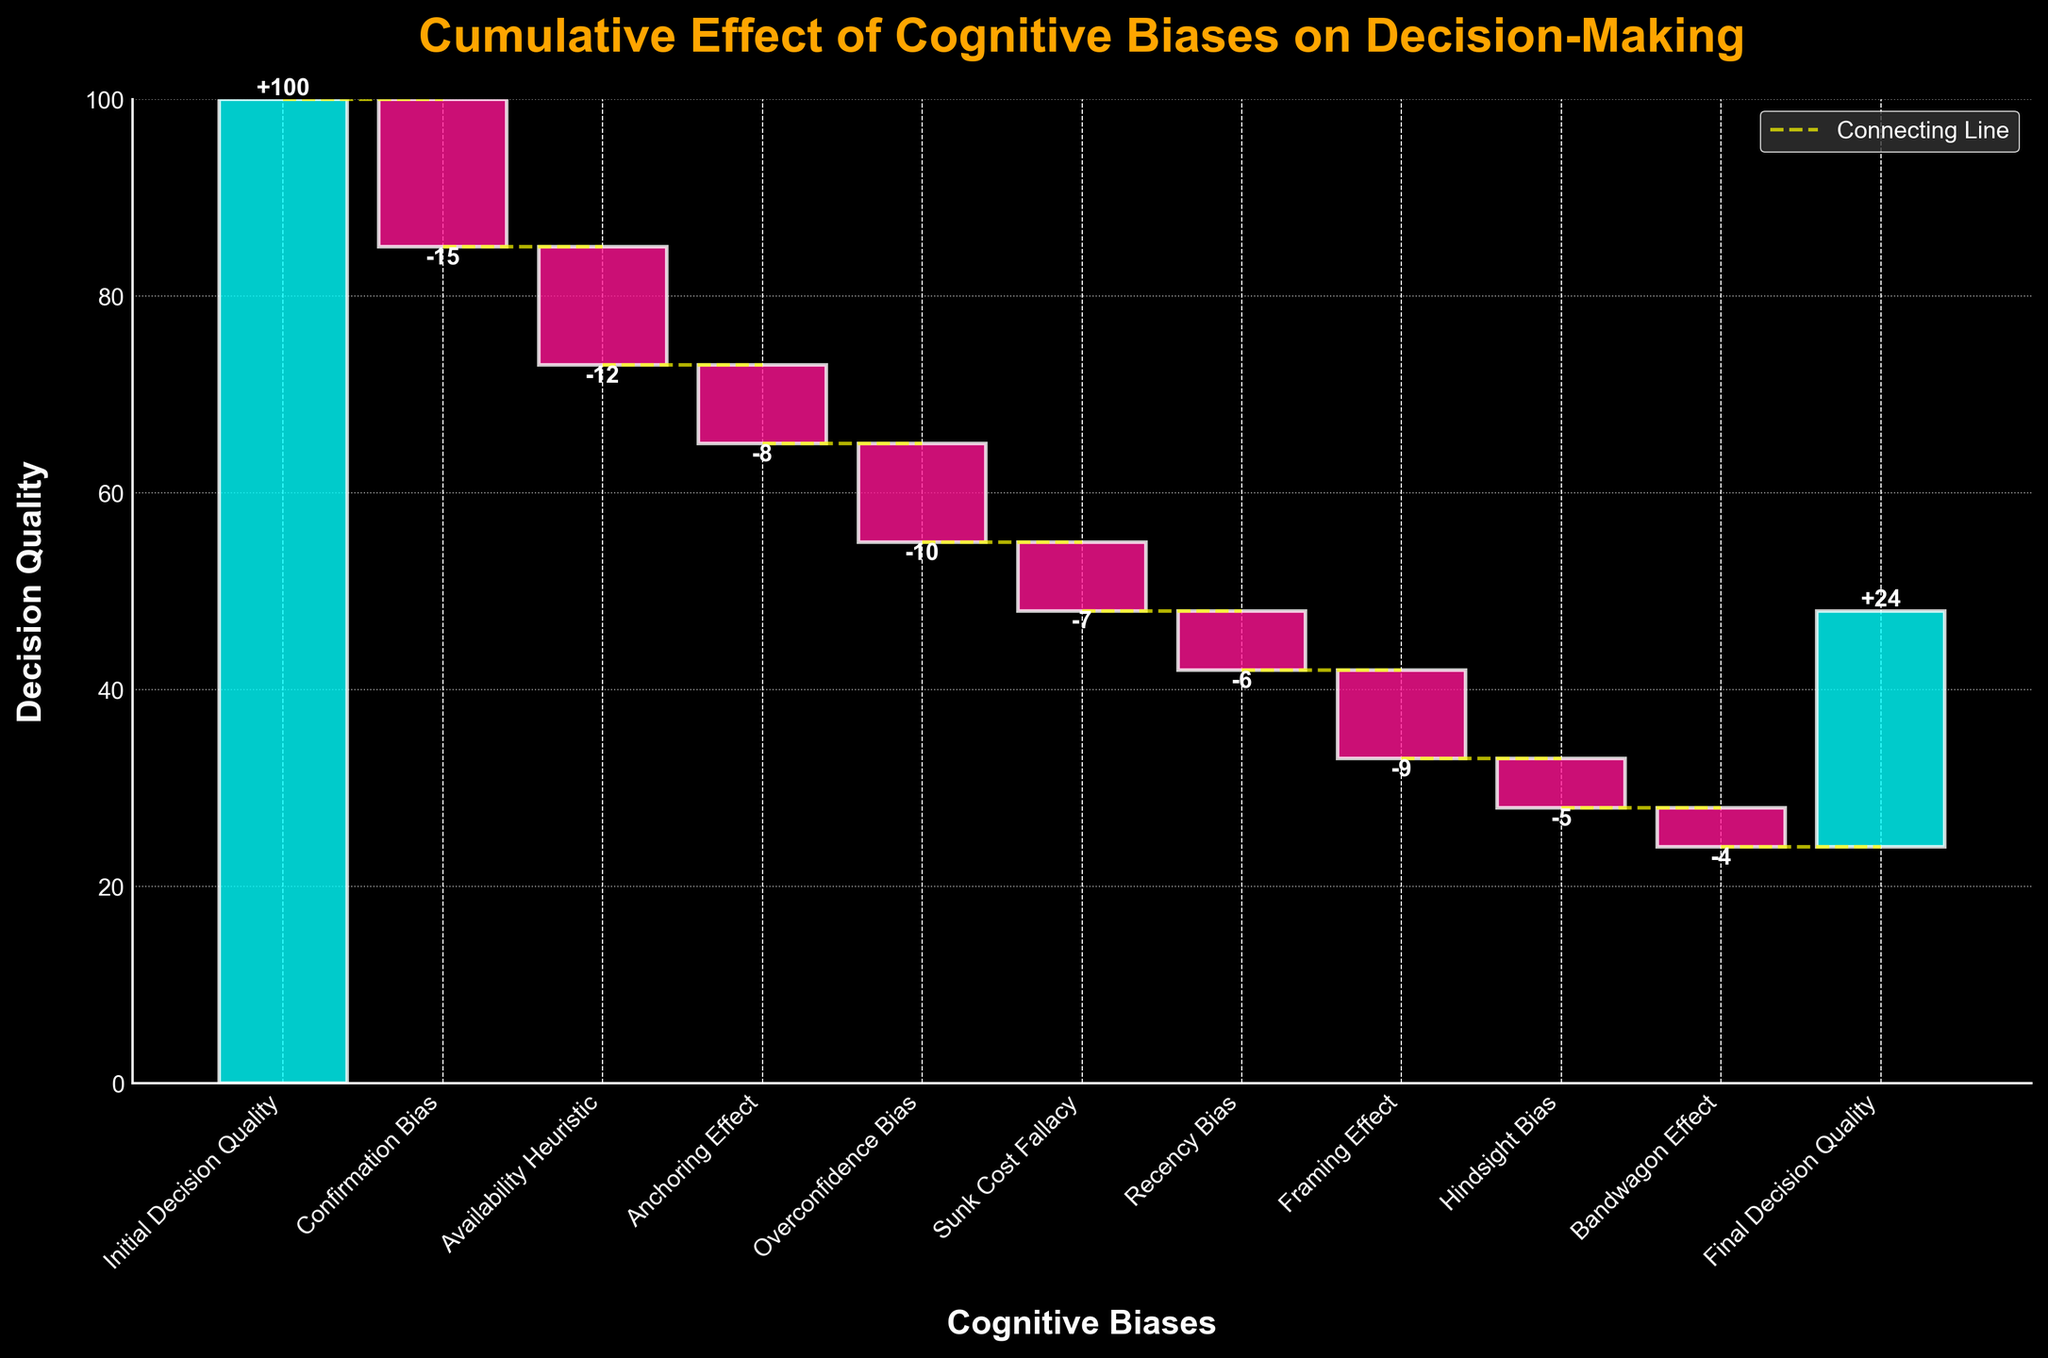What is the initial decision quality? The initial decision quality is clearly labeled at the beginning of the waterfall chart, which is 100.
Answer: 100 What is the final decision quality after accounting for all cognitive biases? The final decision quality is labeled at the end of the waterfall chart, which is 24 as shown in the chart.
Answer: 24 How many cognitive biases are represented in the chart? The chart lists each cognitive bias category along the x-axis. Counting them gives us 9 biases.
Answer: 9 Which cognitive bias has the largest negative impact on decision quality? By comparing the height of each negative bar, the confirmation bias has the largest negative value of -15.
Answer: Confirmation Bias Which cognitive bias has the smallest negative impact on decision quality? By comparing the height of each negative bar, the bandwagon effect has the smallest negative value of -4.
Answer: Bandwagon Effect What is the total cumulative negative effect of all cognitive biases combined? Sum all the negative values of the cognitive biases: -15 + -12 + -8 + -10 + -7 + -6 + -9 + -5 + -4 = -76.
Answer: -76 What is the overall change in decision quality from the initial to the final stage? Subtract the final decision quality from the initial decision quality: 24 - 100 = -76.
Answer: -76 Which cognitive biases have a larger negative impact than the average impact of all biases? First find the average negative impact: (-15 + -12 + -8 + -10 + -7 + -6 + -9 + -5 + -4) / 9 ≈ -8.44. Compare each bias: Confirmation Bias, Availability Heuristic, Overconfidence Bias, and Framing Effect all have impacts greater than -8.44.
Answer: Confirmation Bias, Availability Heuristic, Overconfidence Bias, Framing Effect What is the impact of cognitive biases after the confirmation bias? The waterfall chart shows the impact values including the confirmation bias. Sum the impacts from the availability heuristic to the bandwagon effect: -12 + -8 + -10 + -7 + -6 + -9 + -5 + -4 = -61.
Answer: -61 